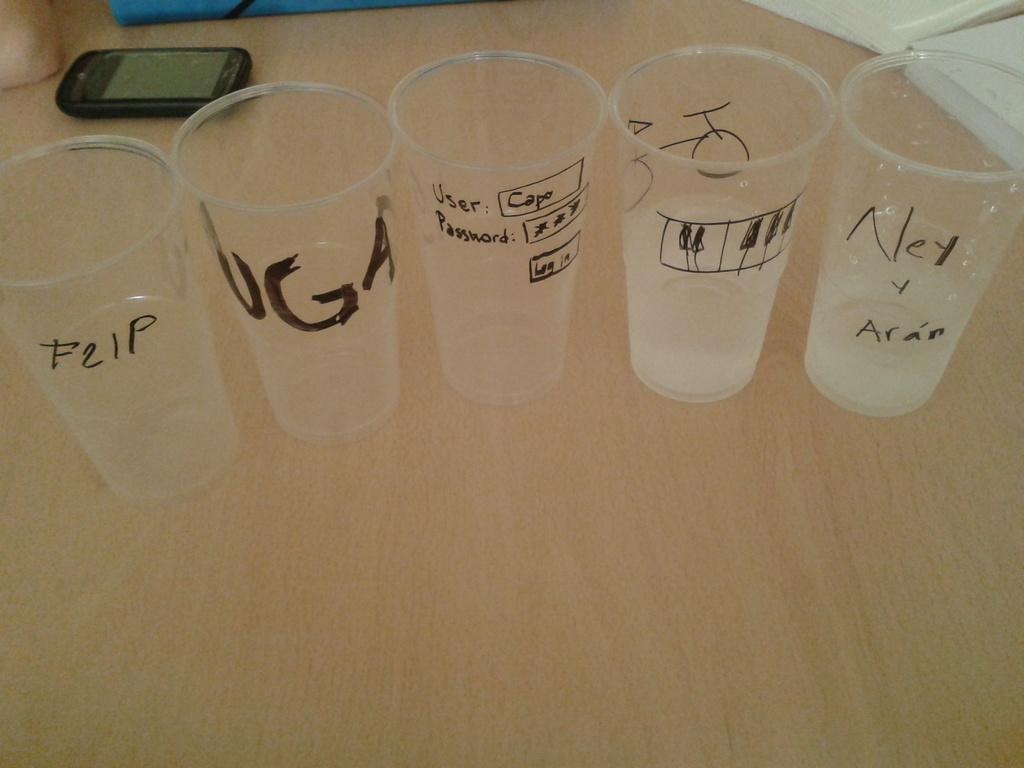<image>
Present a compact description of the photo's key features. Several clear plastic cups that read various things including FLIP, UGA, and other things. 